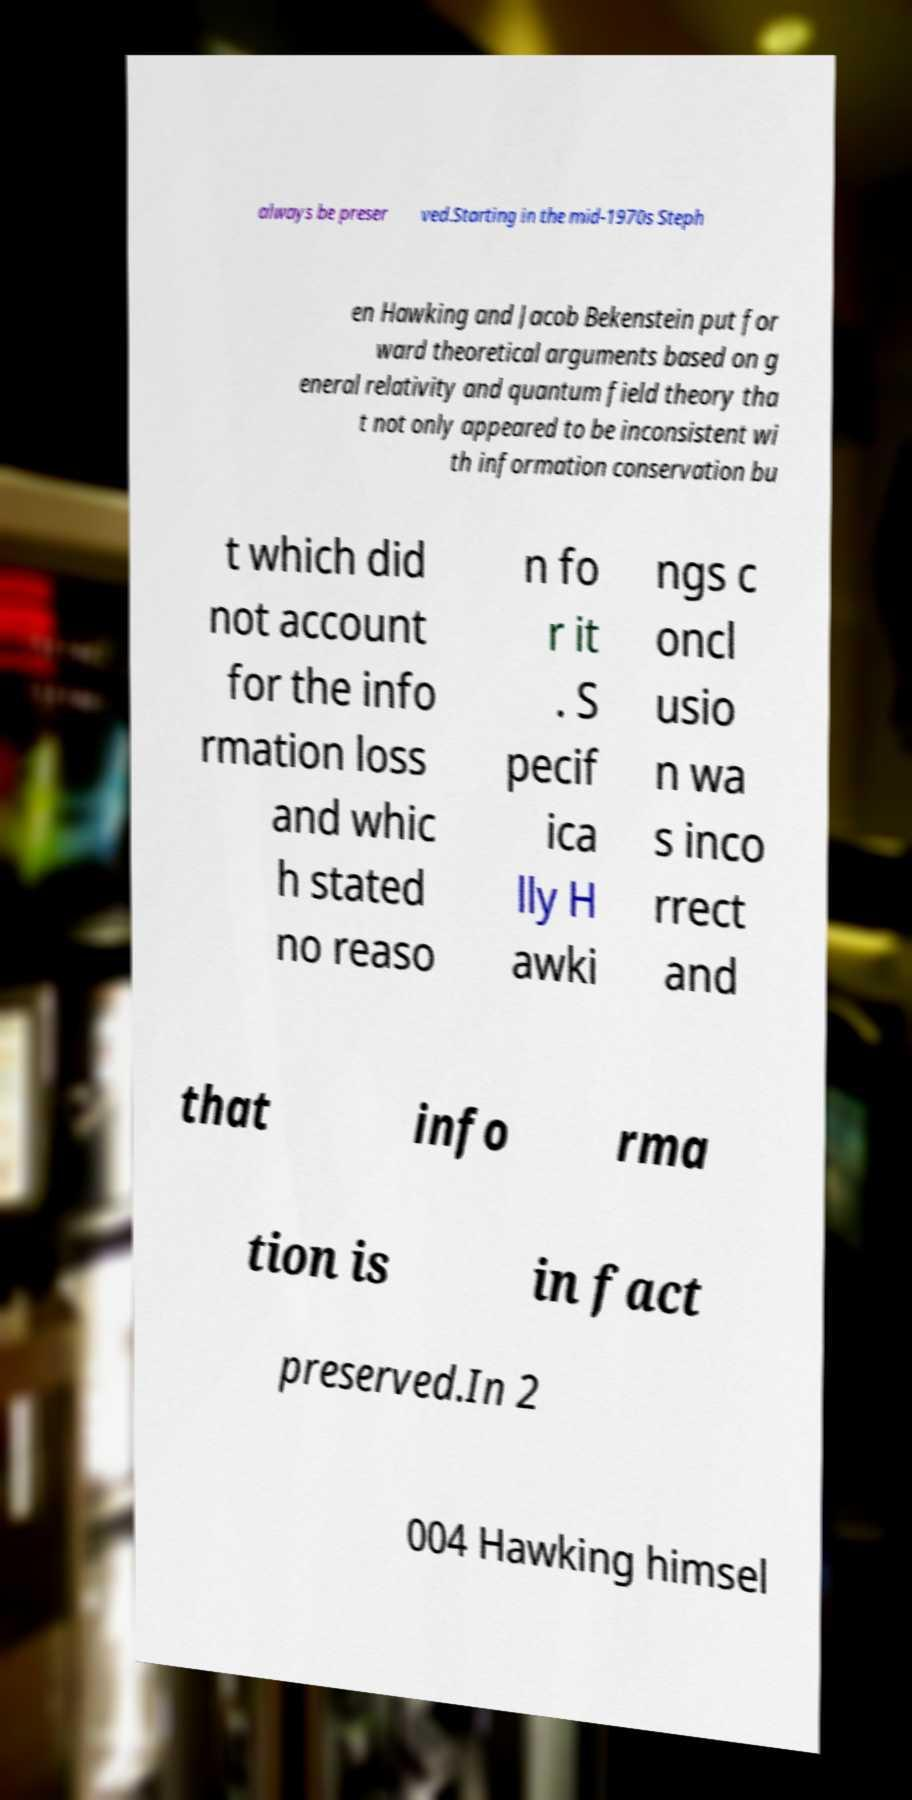For documentation purposes, I need the text within this image transcribed. Could you provide that? always be preser ved.Starting in the mid-1970s Steph en Hawking and Jacob Bekenstein put for ward theoretical arguments based on g eneral relativity and quantum field theory tha t not only appeared to be inconsistent wi th information conservation bu t which did not account for the info rmation loss and whic h stated no reaso n fo r it . S pecif ica lly H awki ngs c oncl usio n wa s inco rrect and that info rma tion is in fact preserved.In 2 004 Hawking himsel 